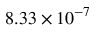<formula> <loc_0><loc_0><loc_500><loc_500>8 . 3 3 \times 1 0 ^ { - 7 }</formula> 